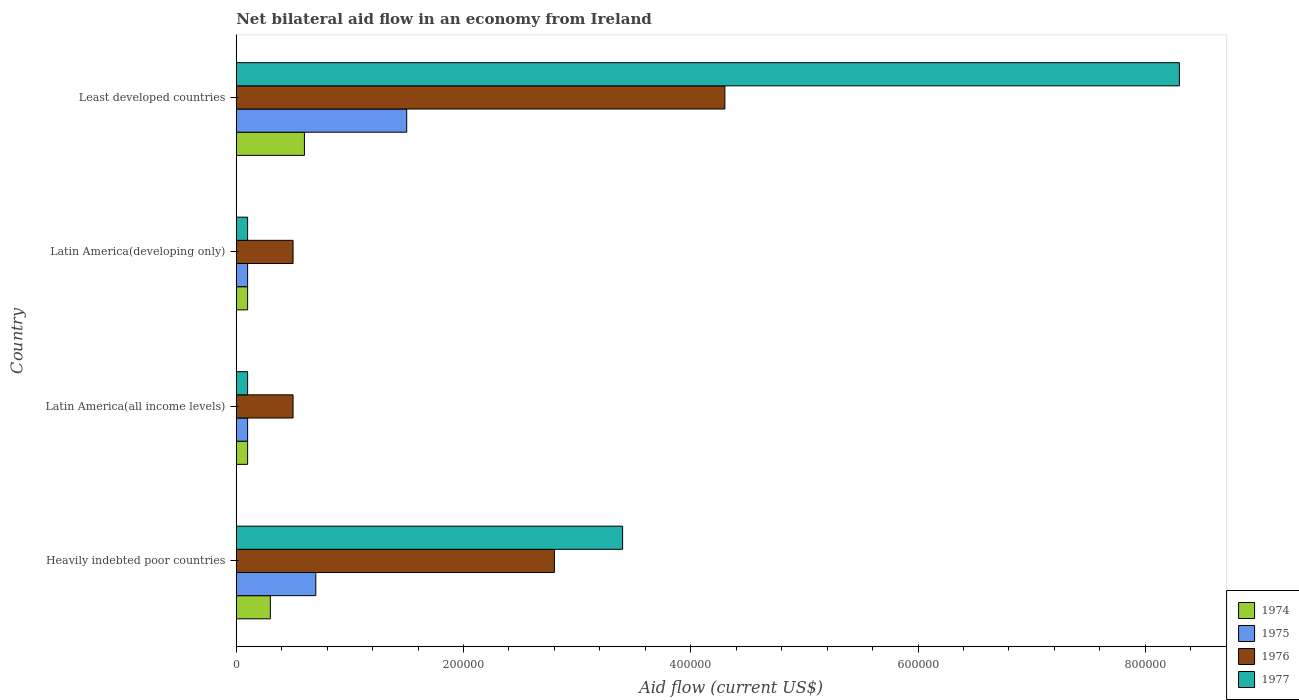Are the number of bars per tick equal to the number of legend labels?
Your response must be concise. Yes. How many bars are there on the 1st tick from the top?
Your response must be concise. 4. How many bars are there on the 2nd tick from the bottom?
Your response must be concise. 4. What is the label of the 4th group of bars from the top?
Keep it short and to the point. Heavily indebted poor countries. What is the net bilateral aid flow in 1977 in Least developed countries?
Provide a short and direct response. 8.30e+05. Across all countries, what is the maximum net bilateral aid flow in 1974?
Provide a short and direct response. 6.00e+04. In which country was the net bilateral aid flow in 1977 maximum?
Provide a short and direct response. Least developed countries. In which country was the net bilateral aid flow in 1977 minimum?
Give a very brief answer. Latin America(all income levels). What is the total net bilateral aid flow in 1977 in the graph?
Your answer should be very brief. 1.19e+06. What is the difference between the net bilateral aid flow in 1975 in Latin America(developing only) and that in Least developed countries?
Your response must be concise. -1.40e+05. What is the average net bilateral aid flow in 1976 per country?
Offer a very short reply. 2.02e+05. What is the difference between the net bilateral aid flow in 1977 and net bilateral aid flow in 1976 in Heavily indebted poor countries?
Provide a succinct answer. 6.00e+04. In how many countries, is the net bilateral aid flow in 1976 greater than 280000 US$?
Ensure brevity in your answer.  1. Is the net bilateral aid flow in 1976 in Heavily indebted poor countries less than that in Latin America(all income levels)?
Make the answer very short. No. Is the difference between the net bilateral aid flow in 1977 in Latin America(developing only) and Least developed countries greater than the difference between the net bilateral aid flow in 1976 in Latin America(developing only) and Least developed countries?
Your response must be concise. No. What is the difference between the highest and the lowest net bilateral aid flow in 1975?
Offer a very short reply. 1.40e+05. Is it the case that in every country, the sum of the net bilateral aid flow in 1976 and net bilateral aid flow in 1974 is greater than the sum of net bilateral aid flow in 1977 and net bilateral aid flow in 1975?
Make the answer very short. No. What does the 4th bar from the top in Latin America(developing only) represents?
Your answer should be compact. 1974. What is the difference between two consecutive major ticks on the X-axis?
Provide a short and direct response. 2.00e+05. How are the legend labels stacked?
Make the answer very short. Vertical. What is the title of the graph?
Ensure brevity in your answer.  Net bilateral aid flow in an economy from Ireland. Does "2003" appear as one of the legend labels in the graph?
Your response must be concise. No. What is the label or title of the X-axis?
Make the answer very short. Aid flow (current US$). What is the Aid flow (current US$) in 1974 in Heavily indebted poor countries?
Keep it short and to the point. 3.00e+04. What is the Aid flow (current US$) of 1976 in Heavily indebted poor countries?
Make the answer very short. 2.80e+05. What is the Aid flow (current US$) of 1975 in Latin America(all income levels)?
Offer a very short reply. 10000. What is the Aid flow (current US$) in 1977 in Latin America(all income levels)?
Give a very brief answer. 10000. What is the Aid flow (current US$) of 1974 in Latin America(developing only)?
Your answer should be very brief. 10000. What is the Aid flow (current US$) of 1975 in Latin America(developing only)?
Keep it short and to the point. 10000. What is the Aid flow (current US$) of 1974 in Least developed countries?
Ensure brevity in your answer.  6.00e+04. What is the Aid flow (current US$) of 1975 in Least developed countries?
Your answer should be very brief. 1.50e+05. What is the Aid flow (current US$) of 1976 in Least developed countries?
Your response must be concise. 4.30e+05. What is the Aid flow (current US$) in 1977 in Least developed countries?
Keep it short and to the point. 8.30e+05. Across all countries, what is the maximum Aid flow (current US$) in 1974?
Your answer should be very brief. 6.00e+04. Across all countries, what is the maximum Aid flow (current US$) in 1977?
Ensure brevity in your answer.  8.30e+05. Across all countries, what is the minimum Aid flow (current US$) of 1976?
Your response must be concise. 5.00e+04. Across all countries, what is the minimum Aid flow (current US$) of 1977?
Keep it short and to the point. 10000. What is the total Aid flow (current US$) of 1974 in the graph?
Your response must be concise. 1.10e+05. What is the total Aid flow (current US$) in 1976 in the graph?
Ensure brevity in your answer.  8.10e+05. What is the total Aid flow (current US$) in 1977 in the graph?
Make the answer very short. 1.19e+06. What is the difference between the Aid flow (current US$) of 1974 in Heavily indebted poor countries and that in Latin America(all income levels)?
Give a very brief answer. 2.00e+04. What is the difference between the Aid flow (current US$) in 1976 in Heavily indebted poor countries and that in Latin America(all income levels)?
Keep it short and to the point. 2.30e+05. What is the difference between the Aid flow (current US$) in 1975 in Heavily indebted poor countries and that in Least developed countries?
Keep it short and to the point. -8.00e+04. What is the difference between the Aid flow (current US$) of 1976 in Heavily indebted poor countries and that in Least developed countries?
Offer a very short reply. -1.50e+05. What is the difference between the Aid flow (current US$) in 1977 in Heavily indebted poor countries and that in Least developed countries?
Your answer should be very brief. -4.90e+05. What is the difference between the Aid flow (current US$) in 1974 in Latin America(all income levels) and that in Latin America(developing only)?
Offer a terse response. 0. What is the difference between the Aid flow (current US$) in 1975 in Latin America(all income levels) and that in Latin America(developing only)?
Ensure brevity in your answer.  0. What is the difference between the Aid flow (current US$) of 1976 in Latin America(all income levels) and that in Least developed countries?
Offer a very short reply. -3.80e+05. What is the difference between the Aid flow (current US$) of 1977 in Latin America(all income levels) and that in Least developed countries?
Make the answer very short. -8.20e+05. What is the difference between the Aid flow (current US$) in 1974 in Latin America(developing only) and that in Least developed countries?
Keep it short and to the point. -5.00e+04. What is the difference between the Aid flow (current US$) of 1975 in Latin America(developing only) and that in Least developed countries?
Give a very brief answer. -1.40e+05. What is the difference between the Aid flow (current US$) of 1976 in Latin America(developing only) and that in Least developed countries?
Your answer should be very brief. -3.80e+05. What is the difference between the Aid flow (current US$) of 1977 in Latin America(developing only) and that in Least developed countries?
Ensure brevity in your answer.  -8.20e+05. What is the difference between the Aid flow (current US$) in 1974 in Heavily indebted poor countries and the Aid flow (current US$) in 1975 in Latin America(all income levels)?
Your response must be concise. 2.00e+04. What is the difference between the Aid flow (current US$) of 1974 in Heavily indebted poor countries and the Aid flow (current US$) of 1977 in Latin America(all income levels)?
Ensure brevity in your answer.  2.00e+04. What is the difference between the Aid flow (current US$) in 1975 in Heavily indebted poor countries and the Aid flow (current US$) in 1977 in Latin America(all income levels)?
Keep it short and to the point. 6.00e+04. What is the difference between the Aid flow (current US$) in 1974 in Heavily indebted poor countries and the Aid flow (current US$) in 1977 in Latin America(developing only)?
Make the answer very short. 2.00e+04. What is the difference between the Aid flow (current US$) of 1976 in Heavily indebted poor countries and the Aid flow (current US$) of 1977 in Latin America(developing only)?
Make the answer very short. 2.70e+05. What is the difference between the Aid flow (current US$) of 1974 in Heavily indebted poor countries and the Aid flow (current US$) of 1976 in Least developed countries?
Your answer should be very brief. -4.00e+05. What is the difference between the Aid flow (current US$) in 1974 in Heavily indebted poor countries and the Aid flow (current US$) in 1977 in Least developed countries?
Give a very brief answer. -8.00e+05. What is the difference between the Aid flow (current US$) of 1975 in Heavily indebted poor countries and the Aid flow (current US$) of 1976 in Least developed countries?
Ensure brevity in your answer.  -3.60e+05. What is the difference between the Aid flow (current US$) in 1975 in Heavily indebted poor countries and the Aid flow (current US$) in 1977 in Least developed countries?
Offer a very short reply. -7.60e+05. What is the difference between the Aid flow (current US$) in 1976 in Heavily indebted poor countries and the Aid flow (current US$) in 1977 in Least developed countries?
Your answer should be compact. -5.50e+05. What is the difference between the Aid flow (current US$) in 1974 in Latin America(all income levels) and the Aid flow (current US$) in 1976 in Latin America(developing only)?
Offer a very short reply. -4.00e+04. What is the difference between the Aid flow (current US$) in 1975 in Latin America(all income levels) and the Aid flow (current US$) in 1977 in Latin America(developing only)?
Make the answer very short. 0. What is the difference between the Aid flow (current US$) of 1976 in Latin America(all income levels) and the Aid flow (current US$) of 1977 in Latin America(developing only)?
Your answer should be very brief. 4.00e+04. What is the difference between the Aid flow (current US$) of 1974 in Latin America(all income levels) and the Aid flow (current US$) of 1975 in Least developed countries?
Your answer should be compact. -1.40e+05. What is the difference between the Aid flow (current US$) of 1974 in Latin America(all income levels) and the Aid flow (current US$) of 1976 in Least developed countries?
Your answer should be very brief. -4.20e+05. What is the difference between the Aid flow (current US$) in 1974 in Latin America(all income levels) and the Aid flow (current US$) in 1977 in Least developed countries?
Your answer should be compact. -8.20e+05. What is the difference between the Aid flow (current US$) in 1975 in Latin America(all income levels) and the Aid flow (current US$) in 1976 in Least developed countries?
Offer a terse response. -4.20e+05. What is the difference between the Aid flow (current US$) of 1975 in Latin America(all income levels) and the Aid flow (current US$) of 1977 in Least developed countries?
Keep it short and to the point. -8.20e+05. What is the difference between the Aid flow (current US$) in 1976 in Latin America(all income levels) and the Aid flow (current US$) in 1977 in Least developed countries?
Your answer should be compact. -7.80e+05. What is the difference between the Aid flow (current US$) in 1974 in Latin America(developing only) and the Aid flow (current US$) in 1976 in Least developed countries?
Your answer should be compact. -4.20e+05. What is the difference between the Aid flow (current US$) in 1974 in Latin America(developing only) and the Aid flow (current US$) in 1977 in Least developed countries?
Keep it short and to the point. -8.20e+05. What is the difference between the Aid flow (current US$) of 1975 in Latin America(developing only) and the Aid flow (current US$) of 1976 in Least developed countries?
Your answer should be compact. -4.20e+05. What is the difference between the Aid flow (current US$) in 1975 in Latin America(developing only) and the Aid flow (current US$) in 1977 in Least developed countries?
Provide a succinct answer. -8.20e+05. What is the difference between the Aid flow (current US$) in 1976 in Latin America(developing only) and the Aid flow (current US$) in 1977 in Least developed countries?
Give a very brief answer. -7.80e+05. What is the average Aid flow (current US$) in 1974 per country?
Your answer should be very brief. 2.75e+04. What is the average Aid flow (current US$) of 1976 per country?
Offer a very short reply. 2.02e+05. What is the average Aid flow (current US$) in 1977 per country?
Keep it short and to the point. 2.98e+05. What is the difference between the Aid flow (current US$) in 1974 and Aid flow (current US$) in 1975 in Heavily indebted poor countries?
Provide a short and direct response. -4.00e+04. What is the difference between the Aid flow (current US$) in 1974 and Aid flow (current US$) in 1977 in Heavily indebted poor countries?
Offer a terse response. -3.10e+05. What is the difference between the Aid flow (current US$) of 1975 and Aid flow (current US$) of 1976 in Heavily indebted poor countries?
Keep it short and to the point. -2.10e+05. What is the difference between the Aid flow (current US$) in 1975 and Aid flow (current US$) in 1977 in Heavily indebted poor countries?
Your answer should be very brief. -2.70e+05. What is the difference between the Aid flow (current US$) in 1976 and Aid flow (current US$) in 1977 in Heavily indebted poor countries?
Your answer should be very brief. -6.00e+04. What is the difference between the Aid flow (current US$) of 1975 and Aid flow (current US$) of 1976 in Latin America(all income levels)?
Offer a very short reply. -4.00e+04. What is the difference between the Aid flow (current US$) of 1975 and Aid flow (current US$) of 1977 in Latin America(all income levels)?
Ensure brevity in your answer.  0. What is the difference between the Aid flow (current US$) of 1976 and Aid flow (current US$) of 1977 in Latin America(all income levels)?
Provide a short and direct response. 4.00e+04. What is the difference between the Aid flow (current US$) of 1974 and Aid flow (current US$) of 1976 in Latin America(developing only)?
Provide a short and direct response. -4.00e+04. What is the difference between the Aid flow (current US$) of 1974 and Aid flow (current US$) of 1977 in Latin America(developing only)?
Ensure brevity in your answer.  0. What is the difference between the Aid flow (current US$) of 1975 and Aid flow (current US$) of 1977 in Latin America(developing only)?
Give a very brief answer. 0. What is the difference between the Aid flow (current US$) in 1974 and Aid flow (current US$) in 1975 in Least developed countries?
Make the answer very short. -9.00e+04. What is the difference between the Aid flow (current US$) of 1974 and Aid flow (current US$) of 1976 in Least developed countries?
Keep it short and to the point. -3.70e+05. What is the difference between the Aid flow (current US$) in 1974 and Aid flow (current US$) in 1977 in Least developed countries?
Your response must be concise. -7.70e+05. What is the difference between the Aid flow (current US$) in 1975 and Aid flow (current US$) in 1976 in Least developed countries?
Ensure brevity in your answer.  -2.80e+05. What is the difference between the Aid flow (current US$) of 1975 and Aid flow (current US$) of 1977 in Least developed countries?
Offer a very short reply. -6.80e+05. What is the difference between the Aid flow (current US$) of 1976 and Aid flow (current US$) of 1977 in Least developed countries?
Provide a short and direct response. -4.00e+05. What is the ratio of the Aid flow (current US$) in 1975 in Heavily indebted poor countries to that in Latin America(all income levels)?
Your response must be concise. 7. What is the ratio of the Aid flow (current US$) of 1976 in Heavily indebted poor countries to that in Latin America(all income levels)?
Your answer should be very brief. 5.6. What is the ratio of the Aid flow (current US$) of 1977 in Heavily indebted poor countries to that in Latin America(all income levels)?
Your answer should be compact. 34. What is the ratio of the Aid flow (current US$) of 1974 in Heavily indebted poor countries to that in Latin America(developing only)?
Your response must be concise. 3. What is the ratio of the Aid flow (current US$) in 1976 in Heavily indebted poor countries to that in Latin America(developing only)?
Make the answer very short. 5.6. What is the ratio of the Aid flow (current US$) of 1975 in Heavily indebted poor countries to that in Least developed countries?
Your answer should be compact. 0.47. What is the ratio of the Aid flow (current US$) of 1976 in Heavily indebted poor countries to that in Least developed countries?
Offer a terse response. 0.65. What is the ratio of the Aid flow (current US$) of 1977 in Heavily indebted poor countries to that in Least developed countries?
Offer a terse response. 0.41. What is the ratio of the Aid flow (current US$) of 1974 in Latin America(all income levels) to that in Latin America(developing only)?
Give a very brief answer. 1. What is the ratio of the Aid flow (current US$) in 1977 in Latin America(all income levels) to that in Latin America(developing only)?
Offer a very short reply. 1. What is the ratio of the Aid flow (current US$) of 1975 in Latin America(all income levels) to that in Least developed countries?
Your answer should be compact. 0.07. What is the ratio of the Aid flow (current US$) in 1976 in Latin America(all income levels) to that in Least developed countries?
Keep it short and to the point. 0.12. What is the ratio of the Aid flow (current US$) of 1977 in Latin America(all income levels) to that in Least developed countries?
Keep it short and to the point. 0.01. What is the ratio of the Aid flow (current US$) in 1974 in Latin America(developing only) to that in Least developed countries?
Offer a terse response. 0.17. What is the ratio of the Aid flow (current US$) of 1975 in Latin America(developing only) to that in Least developed countries?
Ensure brevity in your answer.  0.07. What is the ratio of the Aid flow (current US$) of 1976 in Latin America(developing only) to that in Least developed countries?
Offer a terse response. 0.12. What is the ratio of the Aid flow (current US$) in 1977 in Latin America(developing only) to that in Least developed countries?
Provide a succinct answer. 0.01. What is the difference between the highest and the second highest Aid flow (current US$) of 1976?
Your response must be concise. 1.50e+05. What is the difference between the highest and the lowest Aid flow (current US$) of 1974?
Ensure brevity in your answer.  5.00e+04. What is the difference between the highest and the lowest Aid flow (current US$) of 1977?
Offer a terse response. 8.20e+05. 